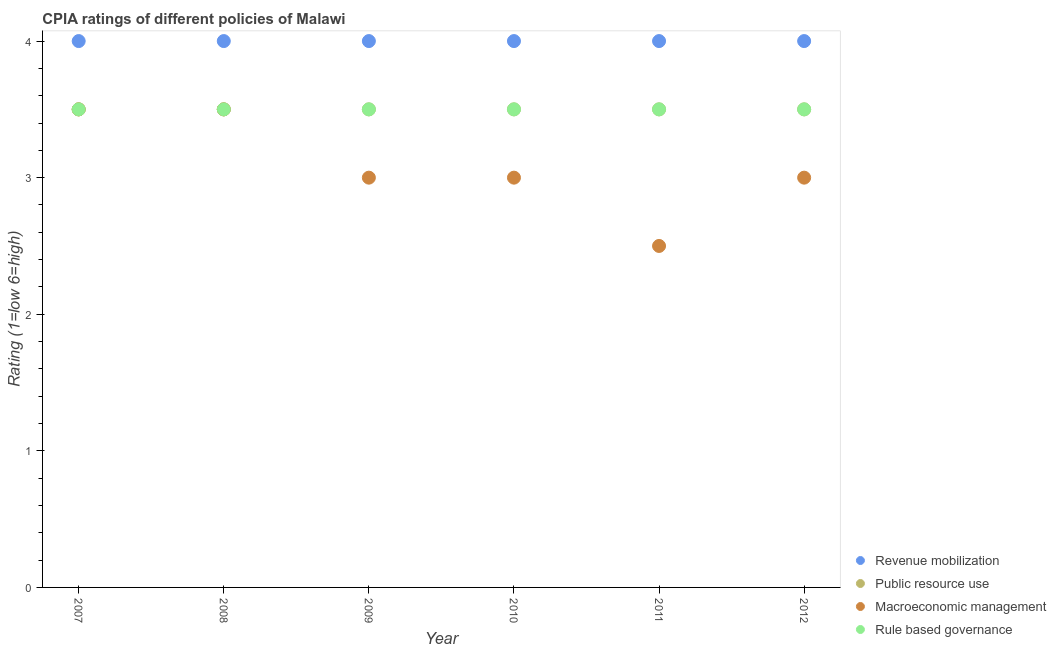Across all years, what is the minimum cpia rating of revenue mobilization?
Provide a succinct answer. 4. In which year was the cpia rating of public resource use maximum?
Your answer should be very brief. 2007. What is the total cpia rating of macroeconomic management in the graph?
Your answer should be compact. 18.5. What is the difference between the cpia rating of rule based governance in 2007 and that in 2009?
Provide a succinct answer. 0. In the year 2009, what is the difference between the cpia rating of revenue mobilization and cpia rating of rule based governance?
Offer a terse response. 0.5. In how many years, is the cpia rating of rule based governance greater than 3.4?
Your response must be concise. 6. Is the difference between the cpia rating of revenue mobilization in 2008 and 2012 greater than the difference between the cpia rating of rule based governance in 2008 and 2012?
Offer a very short reply. No. Is the sum of the cpia rating of rule based governance in 2008 and 2009 greater than the maximum cpia rating of revenue mobilization across all years?
Ensure brevity in your answer.  Yes. Is it the case that in every year, the sum of the cpia rating of revenue mobilization and cpia rating of public resource use is greater than the cpia rating of macroeconomic management?
Provide a short and direct response. Yes. Does the cpia rating of macroeconomic management monotonically increase over the years?
Your answer should be compact. No. Is the cpia rating of rule based governance strictly less than the cpia rating of public resource use over the years?
Offer a terse response. No. Does the graph contain grids?
Provide a short and direct response. No. What is the title of the graph?
Give a very brief answer. CPIA ratings of different policies of Malawi. What is the Rating (1=low 6=high) in Macroeconomic management in 2007?
Your answer should be compact. 3.5. What is the Rating (1=low 6=high) of Revenue mobilization in 2008?
Ensure brevity in your answer.  4. What is the Rating (1=low 6=high) in Public resource use in 2008?
Your answer should be compact. 3.5. What is the Rating (1=low 6=high) in Rule based governance in 2008?
Your answer should be compact. 3.5. What is the Rating (1=low 6=high) in Public resource use in 2009?
Offer a very short reply. 3.5. What is the Rating (1=low 6=high) in Macroeconomic management in 2009?
Your response must be concise. 3. What is the Rating (1=low 6=high) of Macroeconomic management in 2010?
Offer a terse response. 3. What is the Rating (1=low 6=high) of Macroeconomic management in 2011?
Keep it short and to the point. 2.5. What is the Rating (1=low 6=high) of Rule based governance in 2011?
Provide a short and direct response. 3.5. Across all years, what is the maximum Rating (1=low 6=high) in Macroeconomic management?
Offer a very short reply. 3.5. Across all years, what is the maximum Rating (1=low 6=high) of Rule based governance?
Your response must be concise. 3.5. Across all years, what is the minimum Rating (1=low 6=high) in Revenue mobilization?
Keep it short and to the point. 4. Across all years, what is the minimum Rating (1=low 6=high) of Macroeconomic management?
Your answer should be very brief. 2.5. What is the total Rating (1=low 6=high) in Public resource use in the graph?
Offer a very short reply. 21. What is the difference between the Rating (1=low 6=high) in Revenue mobilization in 2007 and that in 2008?
Your answer should be compact. 0. What is the difference between the Rating (1=low 6=high) of Macroeconomic management in 2007 and that in 2008?
Provide a succinct answer. 0. What is the difference between the Rating (1=low 6=high) of Rule based governance in 2007 and that in 2008?
Offer a terse response. 0. What is the difference between the Rating (1=low 6=high) in Public resource use in 2007 and that in 2009?
Provide a short and direct response. 0. What is the difference between the Rating (1=low 6=high) of Revenue mobilization in 2007 and that in 2010?
Provide a short and direct response. 0. What is the difference between the Rating (1=low 6=high) of Rule based governance in 2007 and that in 2010?
Provide a succinct answer. 0. What is the difference between the Rating (1=low 6=high) in Revenue mobilization in 2007 and that in 2012?
Your response must be concise. 0. What is the difference between the Rating (1=low 6=high) of Macroeconomic management in 2007 and that in 2012?
Your response must be concise. 0.5. What is the difference between the Rating (1=low 6=high) in Rule based governance in 2007 and that in 2012?
Provide a succinct answer. 0. What is the difference between the Rating (1=low 6=high) in Revenue mobilization in 2008 and that in 2009?
Provide a short and direct response. 0. What is the difference between the Rating (1=low 6=high) of Public resource use in 2008 and that in 2010?
Your response must be concise. 0. What is the difference between the Rating (1=low 6=high) in Macroeconomic management in 2008 and that in 2010?
Your answer should be compact. 0.5. What is the difference between the Rating (1=low 6=high) of Rule based governance in 2008 and that in 2010?
Offer a terse response. 0. What is the difference between the Rating (1=low 6=high) of Revenue mobilization in 2008 and that in 2011?
Make the answer very short. 0. What is the difference between the Rating (1=low 6=high) in Macroeconomic management in 2008 and that in 2011?
Your answer should be very brief. 1. What is the difference between the Rating (1=low 6=high) of Public resource use in 2008 and that in 2012?
Provide a succinct answer. 0. What is the difference between the Rating (1=low 6=high) of Macroeconomic management in 2008 and that in 2012?
Provide a short and direct response. 0.5. What is the difference between the Rating (1=low 6=high) of Public resource use in 2009 and that in 2010?
Provide a short and direct response. 0. What is the difference between the Rating (1=low 6=high) in Macroeconomic management in 2009 and that in 2010?
Offer a terse response. 0. What is the difference between the Rating (1=low 6=high) in Rule based governance in 2009 and that in 2010?
Ensure brevity in your answer.  0. What is the difference between the Rating (1=low 6=high) of Revenue mobilization in 2009 and that in 2011?
Give a very brief answer. 0. What is the difference between the Rating (1=low 6=high) in Public resource use in 2009 and that in 2011?
Keep it short and to the point. 0. What is the difference between the Rating (1=low 6=high) in Rule based governance in 2009 and that in 2011?
Make the answer very short. 0. What is the difference between the Rating (1=low 6=high) of Revenue mobilization in 2009 and that in 2012?
Your response must be concise. 0. What is the difference between the Rating (1=low 6=high) in Macroeconomic management in 2009 and that in 2012?
Your answer should be compact. 0. What is the difference between the Rating (1=low 6=high) in Rule based governance in 2009 and that in 2012?
Provide a succinct answer. 0. What is the difference between the Rating (1=low 6=high) of Revenue mobilization in 2010 and that in 2011?
Ensure brevity in your answer.  0. What is the difference between the Rating (1=low 6=high) in Macroeconomic management in 2010 and that in 2011?
Offer a very short reply. 0.5. What is the difference between the Rating (1=low 6=high) in Rule based governance in 2010 and that in 2011?
Give a very brief answer. 0. What is the difference between the Rating (1=low 6=high) of Revenue mobilization in 2010 and that in 2012?
Your response must be concise. 0. What is the difference between the Rating (1=low 6=high) of Public resource use in 2010 and that in 2012?
Give a very brief answer. 0. What is the difference between the Rating (1=low 6=high) of Revenue mobilization in 2011 and that in 2012?
Give a very brief answer. 0. What is the difference between the Rating (1=low 6=high) in Macroeconomic management in 2011 and that in 2012?
Your response must be concise. -0.5. What is the difference between the Rating (1=low 6=high) in Rule based governance in 2011 and that in 2012?
Provide a short and direct response. 0. What is the difference between the Rating (1=low 6=high) of Revenue mobilization in 2007 and the Rating (1=low 6=high) of Public resource use in 2008?
Give a very brief answer. 0.5. What is the difference between the Rating (1=low 6=high) in Revenue mobilization in 2007 and the Rating (1=low 6=high) in Macroeconomic management in 2008?
Offer a very short reply. 0.5. What is the difference between the Rating (1=low 6=high) in Revenue mobilization in 2007 and the Rating (1=low 6=high) in Rule based governance in 2008?
Make the answer very short. 0.5. What is the difference between the Rating (1=low 6=high) in Public resource use in 2007 and the Rating (1=low 6=high) in Rule based governance in 2008?
Your answer should be very brief. 0. What is the difference between the Rating (1=low 6=high) in Macroeconomic management in 2007 and the Rating (1=low 6=high) in Rule based governance in 2008?
Offer a very short reply. 0. What is the difference between the Rating (1=low 6=high) in Revenue mobilization in 2007 and the Rating (1=low 6=high) in Macroeconomic management in 2009?
Make the answer very short. 1. What is the difference between the Rating (1=low 6=high) in Revenue mobilization in 2007 and the Rating (1=low 6=high) in Rule based governance in 2009?
Offer a very short reply. 0.5. What is the difference between the Rating (1=low 6=high) in Public resource use in 2007 and the Rating (1=low 6=high) in Macroeconomic management in 2009?
Your response must be concise. 0.5. What is the difference between the Rating (1=low 6=high) in Macroeconomic management in 2007 and the Rating (1=low 6=high) in Rule based governance in 2009?
Keep it short and to the point. 0. What is the difference between the Rating (1=low 6=high) of Revenue mobilization in 2007 and the Rating (1=low 6=high) of Public resource use in 2010?
Your answer should be very brief. 0.5. What is the difference between the Rating (1=low 6=high) of Revenue mobilization in 2007 and the Rating (1=low 6=high) of Macroeconomic management in 2010?
Provide a succinct answer. 1. What is the difference between the Rating (1=low 6=high) of Public resource use in 2007 and the Rating (1=low 6=high) of Macroeconomic management in 2010?
Give a very brief answer. 0.5. What is the difference between the Rating (1=low 6=high) of Revenue mobilization in 2007 and the Rating (1=low 6=high) of Public resource use in 2011?
Your answer should be very brief. 0.5. What is the difference between the Rating (1=low 6=high) in Revenue mobilization in 2007 and the Rating (1=low 6=high) in Macroeconomic management in 2011?
Offer a terse response. 1.5. What is the difference between the Rating (1=low 6=high) in Public resource use in 2007 and the Rating (1=low 6=high) in Macroeconomic management in 2011?
Your answer should be compact. 1. What is the difference between the Rating (1=low 6=high) of Public resource use in 2007 and the Rating (1=low 6=high) of Rule based governance in 2011?
Provide a short and direct response. 0. What is the difference between the Rating (1=low 6=high) of Macroeconomic management in 2007 and the Rating (1=low 6=high) of Rule based governance in 2011?
Ensure brevity in your answer.  0. What is the difference between the Rating (1=low 6=high) in Revenue mobilization in 2007 and the Rating (1=low 6=high) in Public resource use in 2012?
Make the answer very short. 0.5. What is the difference between the Rating (1=low 6=high) in Revenue mobilization in 2007 and the Rating (1=low 6=high) in Macroeconomic management in 2012?
Ensure brevity in your answer.  1. What is the difference between the Rating (1=low 6=high) in Revenue mobilization in 2007 and the Rating (1=low 6=high) in Rule based governance in 2012?
Provide a succinct answer. 0.5. What is the difference between the Rating (1=low 6=high) in Public resource use in 2007 and the Rating (1=low 6=high) in Rule based governance in 2012?
Your answer should be very brief. 0. What is the difference between the Rating (1=low 6=high) of Macroeconomic management in 2007 and the Rating (1=low 6=high) of Rule based governance in 2012?
Keep it short and to the point. 0. What is the difference between the Rating (1=low 6=high) in Public resource use in 2008 and the Rating (1=low 6=high) in Macroeconomic management in 2009?
Provide a short and direct response. 0.5. What is the difference between the Rating (1=low 6=high) in Public resource use in 2008 and the Rating (1=low 6=high) in Rule based governance in 2009?
Make the answer very short. 0. What is the difference between the Rating (1=low 6=high) of Revenue mobilization in 2008 and the Rating (1=low 6=high) of Rule based governance in 2010?
Your answer should be very brief. 0.5. What is the difference between the Rating (1=low 6=high) of Macroeconomic management in 2008 and the Rating (1=low 6=high) of Rule based governance in 2010?
Give a very brief answer. 0. What is the difference between the Rating (1=low 6=high) in Revenue mobilization in 2008 and the Rating (1=low 6=high) in Rule based governance in 2011?
Ensure brevity in your answer.  0.5. What is the difference between the Rating (1=low 6=high) of Public resource use in 2008 and the Rating (1=low 6=high) of Macroeconomic management in 2011?
Make the answer very short. 1. What is the difference between the Rating (1=low 6=high) of Macroeconomic management in 2008 and the Rating (1=low 6=high) of Rule based governance in 2011?
Offer a very short reply. 0. What is the difference between the Rating (1=low 6=high) of Revenue mobilization in 2008 and the Rating (1=low 6=high) of Public resource use in 2012?
Keep it short and to the point. 0.5. What is the difference between the Rating (1=low 6=high) of Public resource use in 2008 and the Rating (1=low 6=high) of Macroeconomic management in 2012?
Ensure brevity in your answer.  0.5. What is the difference between the Rating (1=low 6=high) of Revenue mobilization in 2009 and the Rating (1=low 6=high) of Public resource use in 2010?
Offer a very short reply. 0.5. What is the difference between the Rating (1=low 6=high) of Revenue mobilization in 2009 and the Rating (1=low 6=high) of Macroeconomic management in 2010?
Your response must be concise. 1. What is the difference between the Rating (1=low 6=high) in Public resource use in 2009 and the Rating (1=low 6=high) in Macroeconomic management in 2010?
Your answer should be compact. 0.5. What is the difference between the Rating (1=low 6=high) of Revenue mobilization in 2009 and the Rating (1=low 6=high) of Public resource use in 2011?
Provide a succinct answer. 0.5. What is the difference between the Rating (1=low 6=high) in Public resource use in 2009 and the Rating (1=low 6=high) in Rule based governance in 2011?
Keep it short and to the point. 0. What is the difference between the Rating (1=low 6=high) in Revenue mobilization in 2009 and the Rating (1=low 6=high) in Rule based governance in 2012?
Your answer should be compact. 0.5. What is the difference between the Rating (1=low 6=high) of Public resource use in 2009 and the Rating (1=low 6=high) of Rule based governance in 2012?
Your answer should be very brief. 0. What is the difference between the Rating (1=low 6=high) in Revenue mobilization in 2010 and the Rating (1=low 6=high) in Rule based governance in 2011?
Provide a short and direct response. 0.5. What is the difference between the Rating (1=low 6=high) of Public resource use in 2010 and the Rating (1=low 6=high) of Macroeconomic management in 2011?
Offer a very short reply. 1. What is the difference between the Rating (1=low 6=high) in Macroeconomic management in 2010 and the Rating (1=low 6=high) in Rule based governance in 2011?
Keep it short and to the point. -0.5. What is the difference between the Rating (1=low 6=high) of Revenue mobilization in 2010 and the Rating (1=low 6=high) of Public resource use in 2012?
Make the answer very short. 0.5. What is the difference between the Rating (1=low 6=high) in Public resource use in 2010 and the Rating (1=low 6=high) in Macroeconomic management in 2012?
Keep it short and to the point. 0.5. What is the difference between the Rating (1=low 6=high) of Macroeconomic management in 2010 and the Rating (1=low 6=high) of Rule based governance in 2012?
Offer a very short reply. -0.5. What is the difference between the Rating (1=low 6=high) of Public resource use in 2011 and the Rating (1=low 6=high) of Macroeconomic management in 2012?
Ensure brevity in your answer.  0.5. What is the difference between the Rating (1=low 6=high) in Public resource use in 2011 and the Rating (1=low 6=high) in Rule based governance in 2012?
Offer a terse response. 0. What is the difference between the Rating (1=low 6=high) in Macroeconomic management in 2011 and the Rating (1=low 6=high) in Rule based governance in 2012?
Offer a very short reply. -1. What is the average Rating (1=low 6=high) of Macroeconomic management per year?
Your answer should be compact. 3.08. In the year 2007, what is the difference between the Rating (1=low 6=high) in Revenue mobilization and Rating (1=low 6=high) in Public resource use?
Your response must be concise. 0.5. In the year 2007, what is the difference between the Rating (1=low 6=high) of Revenue mobilization and Rating (1=low 6=high) of Macroeconomic management?
Ensure brevity in your answer.  0.5. In the year 2007, what is the difference between the Rating (1=low 6=high) in Public resource use and Rating (1=low 6=high) in Macroeconomic management?
Make the answer very short. 0. In the year 2007, what is the difference between the Rating (1=low 6=high) in Macroeconomic management and Rating (1=low 6=high) in Rule based governance?
Ensure brevity in your answer.  0. In the year 2008, what is the difference between the Rating (1=low 6=high) in Revenue mobilization and Rating (1=low 6=high) in Public resource use?
Your answer should be compact. 0.5. In the year 2008, what is the difference between the Rating (1=low 6=high) in Revenue mobilization and Rating (1=low 6=high) in Rule based governance?
Give a very brief answer. 0.5. In the year 2008, what is the difference between the Rating (1=low 6=high) of Macroeconomic management and Rating (1=low 6=high) of Rule based governance?
Your response must be concise. 0. In the year 2009, what is the difference between the Rating (1=low 6=high) of Revenue mobilization and Rating (1=low 6=high) of Public resource use?
Ensure brevity in your answer.  0.5. In the year 2009, what is the difference between the Rating (1=low 6=high) of Revenue mobilization and Rating (1=low 6=high) of Macroeconomic management?
Provide a short and direct response. 1. In the year 2009, what is the difference between the Rating (1=low 6=high) in Revenue mobilization and Rating (1=low 6=high) in Rule based governance?
Offer a terse response. 0.5. In the year 2009, what is the difference between the Rating (1=low 6=high) in Public resource use and Rating (1=low 6=high) in Macroeconomic management?
Provide a short and direct response. 0.5. In the year 2009, what is the difference between the Rating (1=low 6=high) of Macroeconomic management and Rating (1=low 6=high) of Rule based governance?
Provide a short and direct response. -0.5. In the year 2010, what is the difference between the Rating (1=low 6=high) in Macroeconomic management and Rating (1=low 6=high) in Rule based governance?
Provide a short and direct response. -0.5. In the year 2011, what is the difference between the Rating (1=low 6=high) of Revenue mobilization and Rating (1=low 6=high) of Public resource use?
Your response must be concise. 0.5. In the year 2011, what is the difference between the Rating (1=low 6=high) in Revenue mobilization and Rating (1=low 6=high) in Macroeconomic management?
Offer a very short reply. 1.5. In the year 2011, what is the difference between the Rating (1=low 6=high) of Revenue mobilization and Rating (1=low 6=high) of Rule based governance?
Ensure brevity in your answer.  0.5. In the year 2011, what is the difference between the Rating (1=low 6=high) in Public resource use and Rating (1=low 6=high) in Macroeconomic management?
Offer a terse response. 1. In the year 2011, what is the difference between the Rating (1=low 6=high) in Macroeconomic management and Rating (1=low 6=high) in Rule based governance?
Provide a short and direct response. -1. In the year 2012, what is the difference between the Rating (1=low 6=high) in Revenue mobilization and Rating (1=low 6=high) in Public resource use?
Your answer should be compact. 0.5. In the year 2012, what is the difference between the Rating (1=low 6=high) in Revenue mobilization and Rating (1=low 6=high) in Macroeconomic management?
Provide a short and direct response. 1. In the year 2012, what is the difference between the Rating (1=low 6=high) of Revenue mobilization and Rating (1=low 6=high) of Rule based governance?
Keep it short and to the point. 0.5. In the year 2012, what is the difference between the Rating (1=low 6=high) of Public resource use and Rating (1=low 6=high) of Macroeconomic management?
Offer a very short reply. 0.5. In the year 2012, what is the difference between the Rating (1=low 6=high) in Public resource use and Rating (1=low 6=high) in Rule based governance?
Your answer should be very brief. 0. What is the ratio of the Rating (1=low 6=high) of Public resource use in 2007 to that in 2008?
Your response must be concise. 1. What is the ratio of the Rating (1=low 6=high) in Macroeconomic management in 2007 to that in 2008?
Offer a terse response. 1. What is the ratio of the Rating (1=low 6=high) in Rule based governance in 2007 to that in 2008?
Offer a terse response. 1. What is the ratio of the Rating (1=low 6=high) of Macroeconomic management in 2007 to that in 2009?
Give a very brief answer. 1.17. What is the ratio of the Rating (1=low 6=high) in Rule based governance in 2007 to that in 2009?
Your answer should be compact. 1. What is the ratio of the Rating (1=low 6=high) in Public resource use in 2007 to that in 2010?
Offer a terse response. 1. What is the ratio of the Rating (1=low 6=high) in Macroeconomic management in 2007 to that in 2010?
Provide a succinct answer. 1.17. What is the ratio of the Rating (1=low 6=high) in Revenue mobilization in 2007 to that in 2011?
Ensure brevity in your answer.  1. What is the ratio of the Rating (1=low 6=high) in Public resource use in 2007 to that in 2011?
Your answer should be very brief. 1. What is the ratio of the Rating (1=low 6=high) in Macroeconomic management in 2007 to that in 2011?
Provide a short and direct response. 1.4. What is the ratio of the Rating (1=low 6=high) of Rule based governance in 2007 to that in 2011?
Your answer should be compact. 1. What is the ratio of the Rating (1=low 6=high) of Rule based governance in 2007 to that in 2012?
Ensure brevity in your answer.  1. What is the ratio of the Rating (1=low 6=high) in Revenue mobilization in 2008 to that in 2009?
Provide a short and direct response. 1. What is the ratio of the Rating (1=low 6=high) in Macroeconomic management in 2008 to that in 2009?
Make the answer very short. 1.17. What is the ratio of the Rating (1=low 6=high) of Revenue mobilization in 2008 to that in 2010?
Your answer should be compact. 1. What is the ratio of the Rating (1=low 6=high) in Macroeconomic management in 2008 to that in 2011?
Your response must be concise. 1.4. What is the ratio of the Rating (1=low 6=high) in Rule based governance in 2008 to that in 2011?
Provide a succinct answer. 1. What is the ratio of the Rating (1=low 6=high) in Revenue mobilization in 2008 to that in 2012?
Your response must be concise. 1. What is the ratio of the Rating (1=low 6=high) of Macroeconomic management in 2008 to that in 2012?
Offer a very short reply. 1.17. What is the ratio of the Rating (1=low 6=high) of Rule based governance in 2008 to that in 2012?
Give a very brief answer. 1. What is the ratio of the Rating (1=low 6=high) in Public resource use in 2009 to that in 2010?
Your response must be concise. 1. What is the ratio of the Rating (1=low 6=high) of Rule based governance in 2009 to that in 2010?
Ensure brevity in your answer.  1. What is the ratio of the Rating (1=low 6=high) in Revenue mobilization in 2009 to that in 2011?
Offer a terse response. 1. What is the ratio of the Rating (1=low 6=high) of Public resource use in 2009 to that in 2011?
Your response must be concise. 1. What is the ratio of the Rating (1=low 6=high) of Macroeconomic management in 2009 to that in 2011?
Give a very brief answer. 1.2. What is the ratio of the Rating (1=low 6=high) of Rule based governance in 2009 to that in 2011?
Make the answer very short. 1. What is the ratio of the Rating (1=low 6=high) in Revenue mobilization in 2009 to that in 2012?
Ensure brevity in your answer.  1. What is the ratio of the Rating (1=low 6=high) in Public resource use in 2009 to that in 2012?
Give a very brief answer. 1. What is the ratio of the Rating (1=low 6=high) of Macroeconomic management in 2009 to that in 2012?
Give a very brief answer. 1. What is the ratio of the Rating (1=low 6=high) in Rule based governance in 2009 to that in 2012?
Give a very brief answer. 1. What is the ratio of the Rating (1=low 6=high) of Rule based governance in 2010 to that in 2012?
Your answer should be compact. 1. What is the ratio of the Rating (1=low 6=high) in Revenue mobilization in 2011 to that in 2012?
Offer a terse response. 1. What is the difference between the highest and the second highest Rating (1=low 6=high) of Revenue mobilization?
Your answer should be compact. 0. What is the difference between the highest and the lowest Rating (1=low 6=high) in Revenue mobilization?
Make the answer very short. 0. What is the difference between the highest and the lowest Rating (1=low 6=high) of Macroeconomic management?
Provide a short and direct response. 1. 